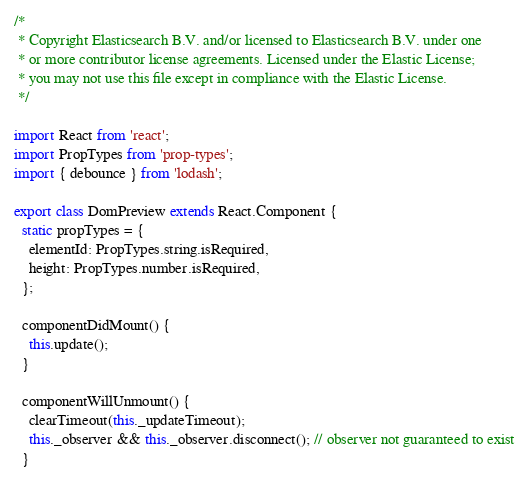Convert code to text. <code><loc_0><loc_0><loc_500><loc_500><_JavaScript_>/*
 * Copyright Elasticsearch B.V. and/or licensed to Elasticsearch B.V. under one
 * or more contributor license agreements. Licensed under the Elastic License;
 * you may not use this file except in compliance with the Elastic License.
 */

import React from 'react';
import PropTypes from 'prop-types';
import { debounce } from 'lodash';

export class DomPreview extends React.Component {
  static propTypes = {
    elementId: PropTypes.string.isRequired,
    height: PropTypes.number.isRequired,
  };

  componentDidMount() {
    this.update();
  }

  componentWillUnmount() {
    clearTimeout(this._updateTimeout);
    this._observer && this._observer.disconnect(); // observer not guaranteed to exist
  }
</code> 